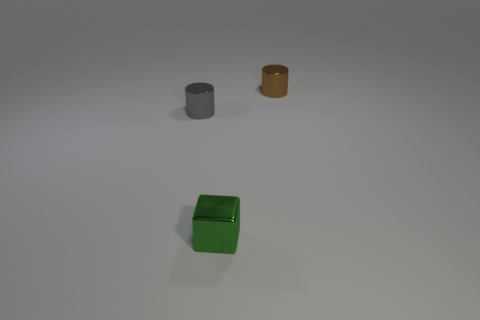Add 3 cylinders. How many objects exist? 6 Subtract all cylinders. How many objects are left? 1 Subtract 0 blue blocks. How many objects are left? 3 Subtract all tiny red cylinders. Subtract all gray metal cylinders. How many objects are left? 2 Add 2 tiny gray things. How many tiny gray things are left? 3 Add 3 small blue cubes. How many small blue cubes exist? 3 